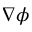Convert formula to latex. <formula><loc_0><loc_0><loc_500><loc_500>\nabla \phi</formula> 